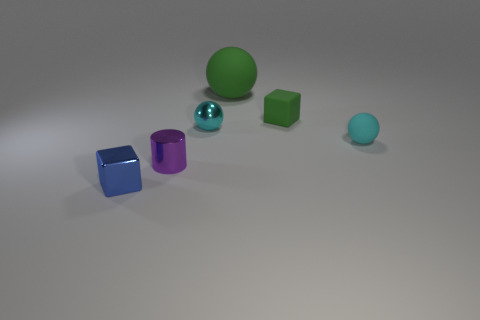There is a matte object that is the same color as the large matte sphere; what is its size?
Provide a succinct answer. Small. Is there a block of the same color as the metal sphere?
Your answer should be very brief. No. What color is the other ball that is the same size as the cyan matte sphere?
Provide a succinct answer. Cyan. What is the tiny cyan thing on the right side of the green matte thing that is on the left side of the tiny rubber thing behind the cyan matte thing made of?
Your response must be concise. Rubber. There is a big matte sphere; is its color the same as the cube right of the blue block?
Your response must be concise. Yes. How many things are small cyan balls that are right of the tiny green cube or matte balls in front of the large thing?
Provide a short and direct response. 1. The green rubber object that is behind the tiny block that is behind the blue metal object is what shape?
Give a very brief answer. Sphere. Is there a red block made of the same material as the purple object?
Ensure brevity in your answer.  No. There is a tiny rubber thing that is the same shape as the cyan shiny object; what color is it?
Make the answer very short. Cyan. Is the number of small metallic cylinders that are behind the tiny rubber cube less than the number of tiny cylinders on the left side of the tiny purple cylinder?
Make the answer very short. No. 